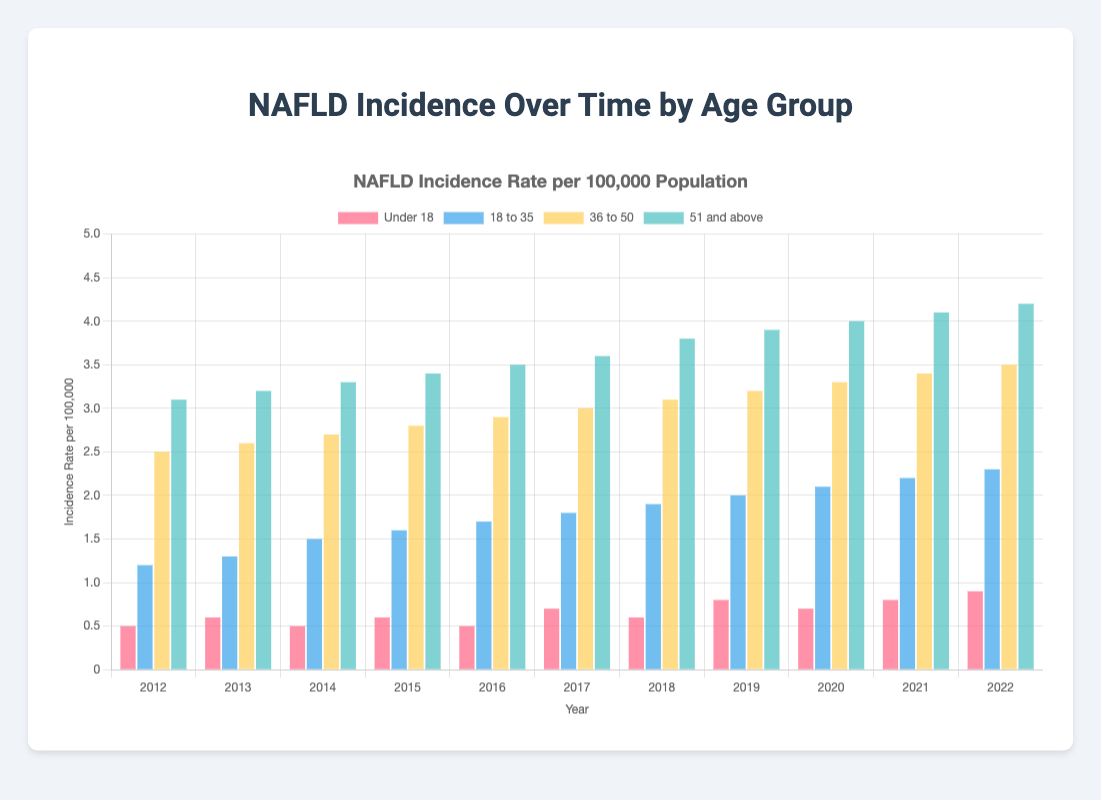What is the incidence rate for the 'Under 18' group in 2022? Look at the 'Under 18' bar for the year 2022, which is pink in color. The height indicates the value is 0.9.
Answer: 0.9 Which age group showed the highest incidence rate in 2021? Check the bars for each age group in 2021. The '51 and above' group has the tallest bar.
Answer: 51 and above Did the incidence rate for the '18 to 35' age group increase or decrease from 2015 to 2020? Compare the height of the '18 to 35' bars in 2015 and 2020. The bar height increased from 1.6 to 2.1.
Answer: Increase What is the difference in incidence rates between the '36 to 50' age group and the '51 and above' age group in 2019? Subtract the value of the '36 to 50' group (3.2) from the value of the '51 and above' group (3.9) in 2019.
Answer: 0.7 Which year had the lowest incidence rate for the 'Under 18' age group? Identify the shortest pink bar between 2012 and 2022. The lowest point is in 2012 and 2014, both at 0.5.
Answer: 2012, 2014 Was there a year when all age groups experienced an increase in incidence rate compared to the previous year? Scan through the bars from one year to the next across all groups. In 2016, rates increased for all groups compared to 2015.
Answer: 2016 What was the average incidence rate for the 'Under 18' group over this decade? Add the values for 'Under 18' from 2012 to 2022 ((0.5+0.6+0.5+0.6+0.5+0.7+0.6+0.8+0.7+0.8+0.9)=7.2) and divide by the number of years (7.2/11).
Answer: 0.65 Which group showed the most significant increase in incidence rate between 2012 and 2022? Calculate the difference for each group from 2012 to 2022 and determine the highest difference. '51 and above' increased from 3.1 to 4.2, the highest increment of 1.1.
Answer: 51 and above 